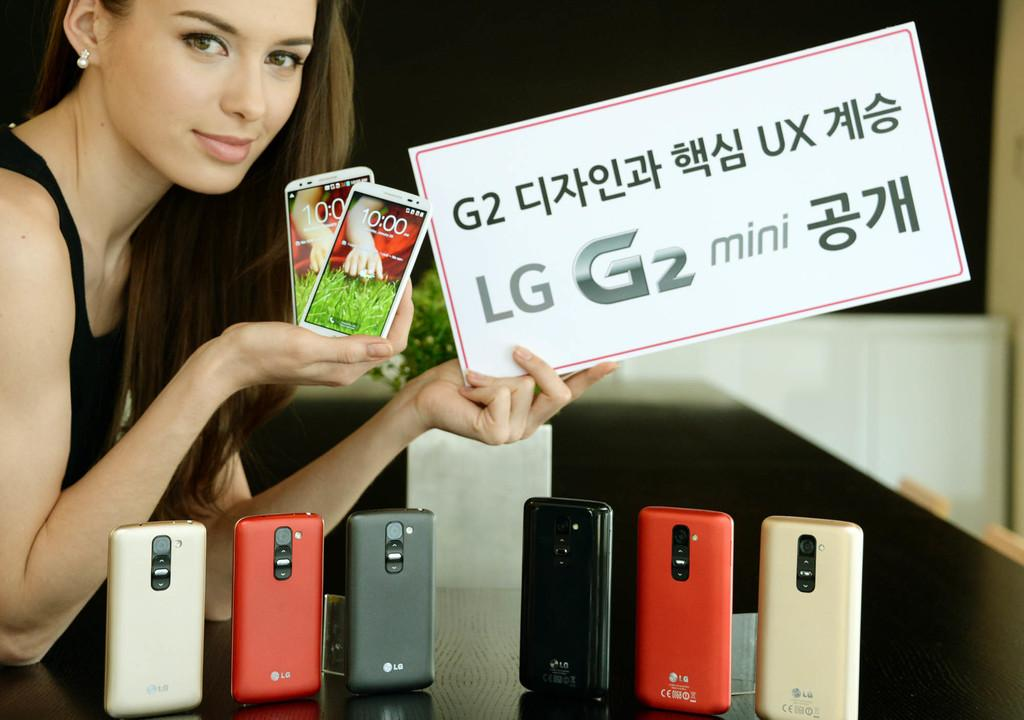<image>
Relay a brief, clear account of the picture shown. A display of red, white, and grey phones with a woman holding an LG sign. 